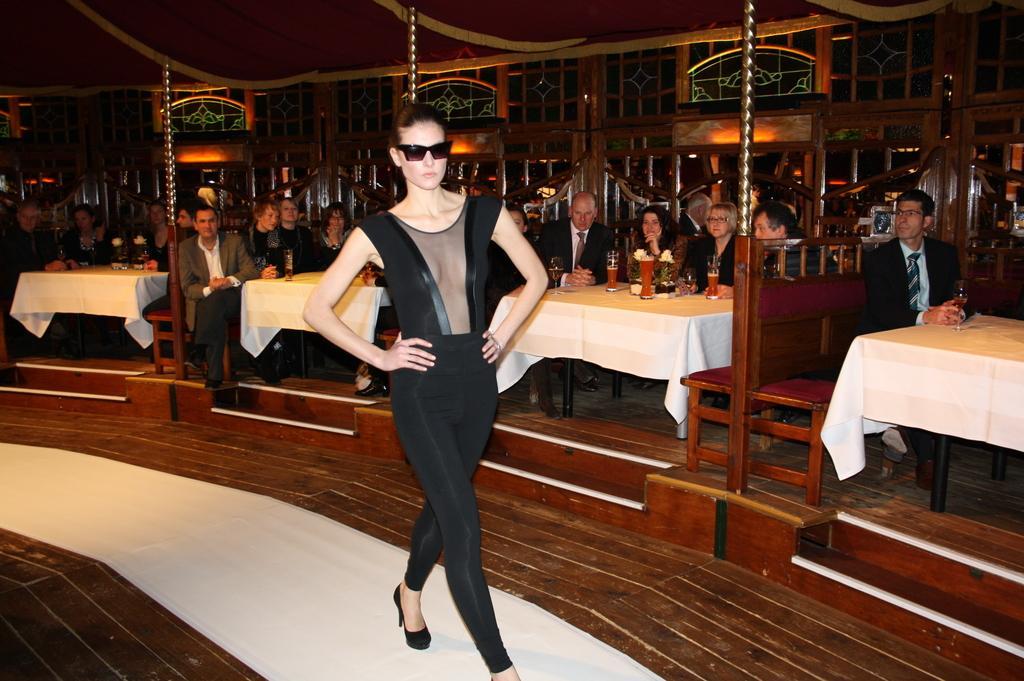In one or two sentences, can you explain what this image depicts? In this Image I see this woman who is wearing a black dress and she is walking on this path. In the background I see number of people who are sitting on chairs and there are tables in front of them and there are few things on it. 